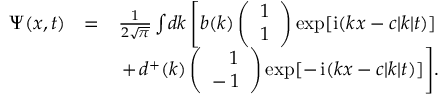Convert formula to latex. <formula><loc_0><loc_0><loc_500><loc_500>\begin{array} { r l r } { \Psi ( { x } , t ) } & { = } & { \frac { 1 } { 2 \sqrt { \pi } } \int \, d k \left [ b ( { k } ) \left ( \begin{array} { c } { 1 } \\ { 1 } \end{array} \right ) \exp [ i ( k x - c | k | t ) ] } \\ & { + \, d ^ { + } ( { k } ) \left ( \begin{array} { c c } { \, 1 } \\ { - \, 1 } \end{array} \right ) \exp [ - \, i ( k x - c | k | t ) ] \right ] \, . } \end{array}</formula> 